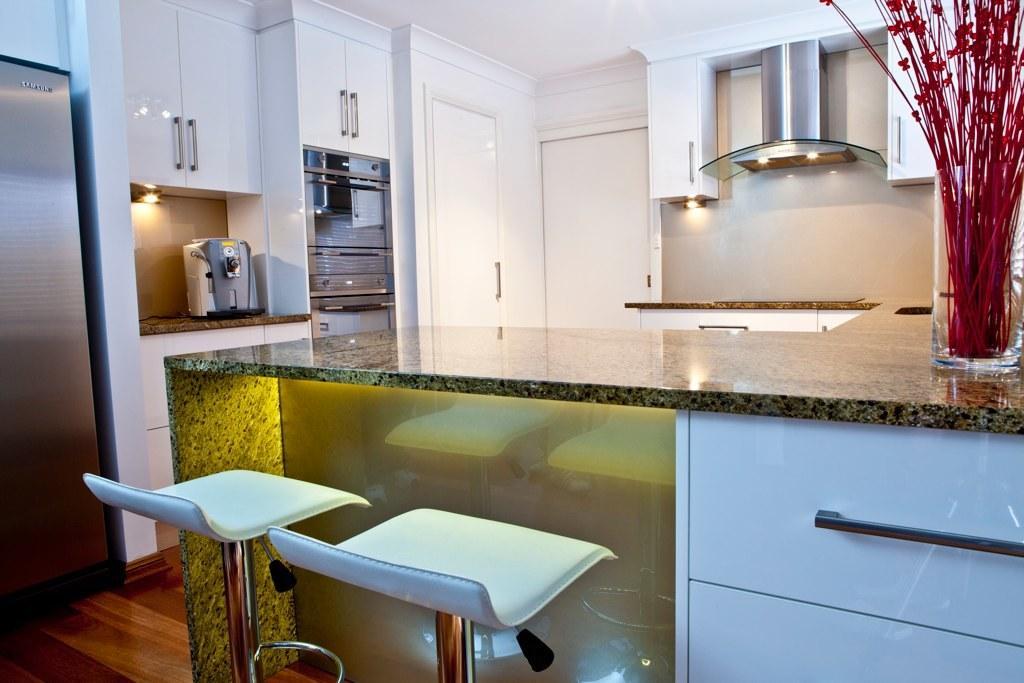Describe this image in one or two sentences. In the picture I can see two stools and there is a table in front of it and there is a flower vase in the right corner and there is a refrigerator and some other objects in the left corner. 